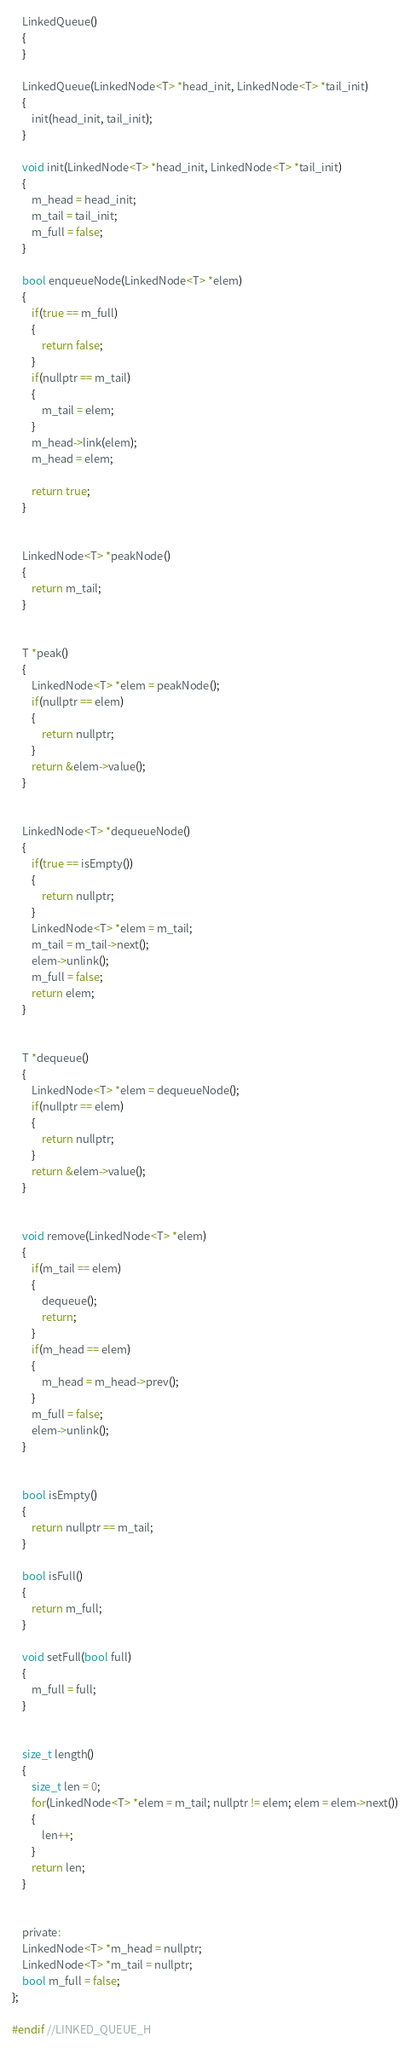Convert code to text. <code><loc_0><loc_0><loc_500><loc_500><_C_>	LinkedQueue()
	{
	}

	LinkedQueue(LinkedNode<T> *head_init, LinkedNode<T> *tail_init)
	{
		init(head_init, tail_init);
	}

	void init(LinkedNode<T> *head_init, LinkedNode<T> *tail_init)
	{
		m_head = head_init;
		m_tail = tail_init;
		m_full = false;
	}

	bool enqueueNode(LinkedNode<T> *elem)
	{
		if(true == m_full)
		{
			return false;
		}
		if(nullptr == m_tail)
		{
			m_tail = elem;
		}
		m_head->link(elem);
		m_head = elem;
		
		return true;
	}


	LinkedNode<T> *peakNode()
	{
		return m_tail;
	}


	T *peak()
	{
		LinkedNode<T> *elem = peakNode();
		if(nullptr == elem)
		{
			return nullptr;
		}
		return &elem->value();
	}


	LinkedNode<T> *dequeueNode()
	{
		if(true == isEmpty())
		{
			return nullptr;
		}
		LinkedNode<T> *elem = m_tail;
		m_tail = m_tail->next();
		elem->unlink();
		m_full = false;
		return elem;
	}


	T *dequeue()
	{
		LinkedNode<T> *elem = dequeueNode();
		if(nullptr == elem)
		{
			return nullptr;
		}
		return &elem->value();
	}


	void remove(LinkedNode<T> *elem)
	{
		if(m_tail == elem)
		{
			dequeue();
			return;
		}
		if(m_head == elem)
		{
			m_head = m_head->prev();
		}
		m_full = false;
		elem->unlink();
	}


	bool isEmpty()
	{
		return nullptr == m_tail;
	}

	bool isFull()
	{
		return m_full;
	}
	
	void setFull(bool full)
	{
		m_full = full;
	}


	size_t length()
	{
		size_t len = 0;
		for(LinkedNode<T> *elem = m_tail; nullptr != elem; elem = elem->next())
		{
			len++;
		}
		return len;
	}


	private:
	LinkedNode<T> *m_head = nullptr;
	LinkedNode<T> *m_tail = nullptr;
	bool m_full = false;
};

#endif //LINKED_QUEUE_H
</code> 